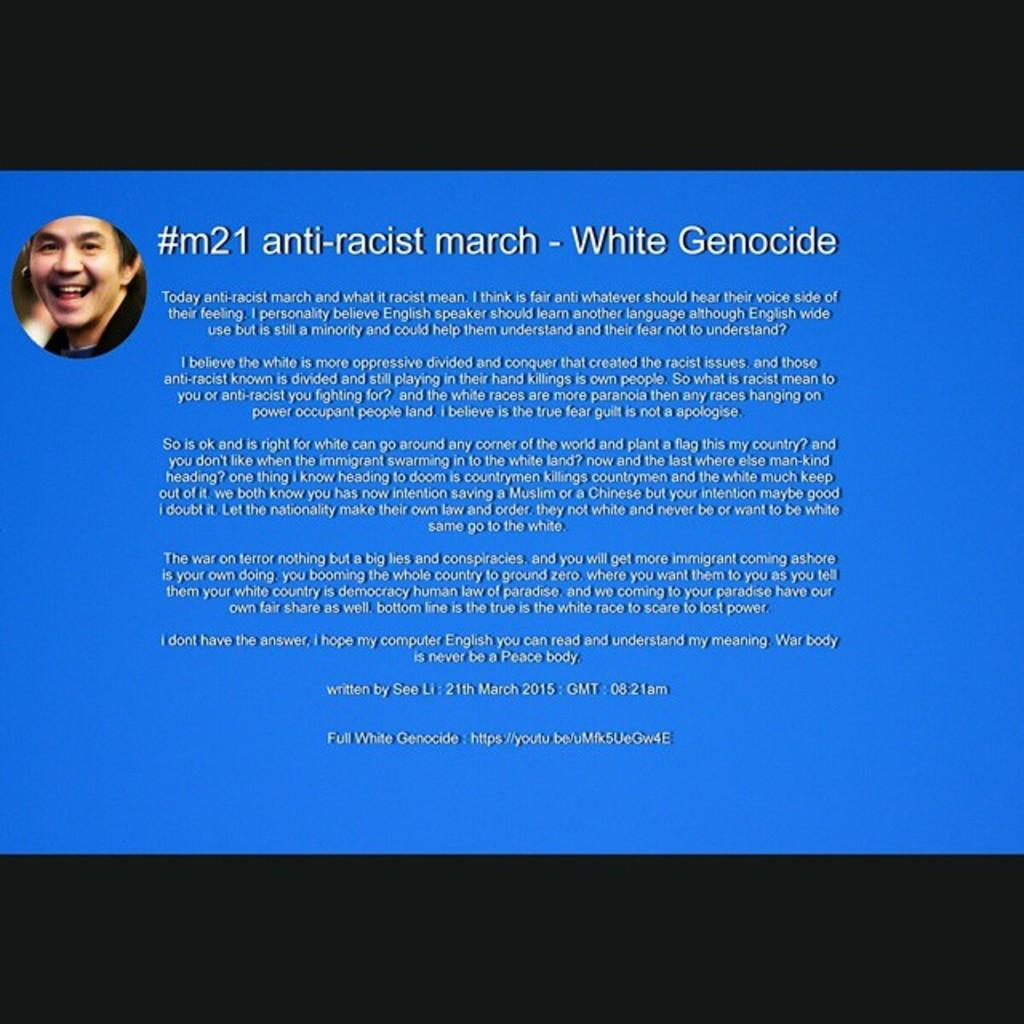What can be found in the image? There is some information in the image. Can you describe the person visible in the image? There is a person visible on a blue surface. What color are the borders at the top and bottom of the image? There is a black border at the top and bottom of the image. What type of vase is being used for teaching in the image? There is no vase or teaching activity present in the image. How is the lace being used in the image? There is no lace present in the image. 